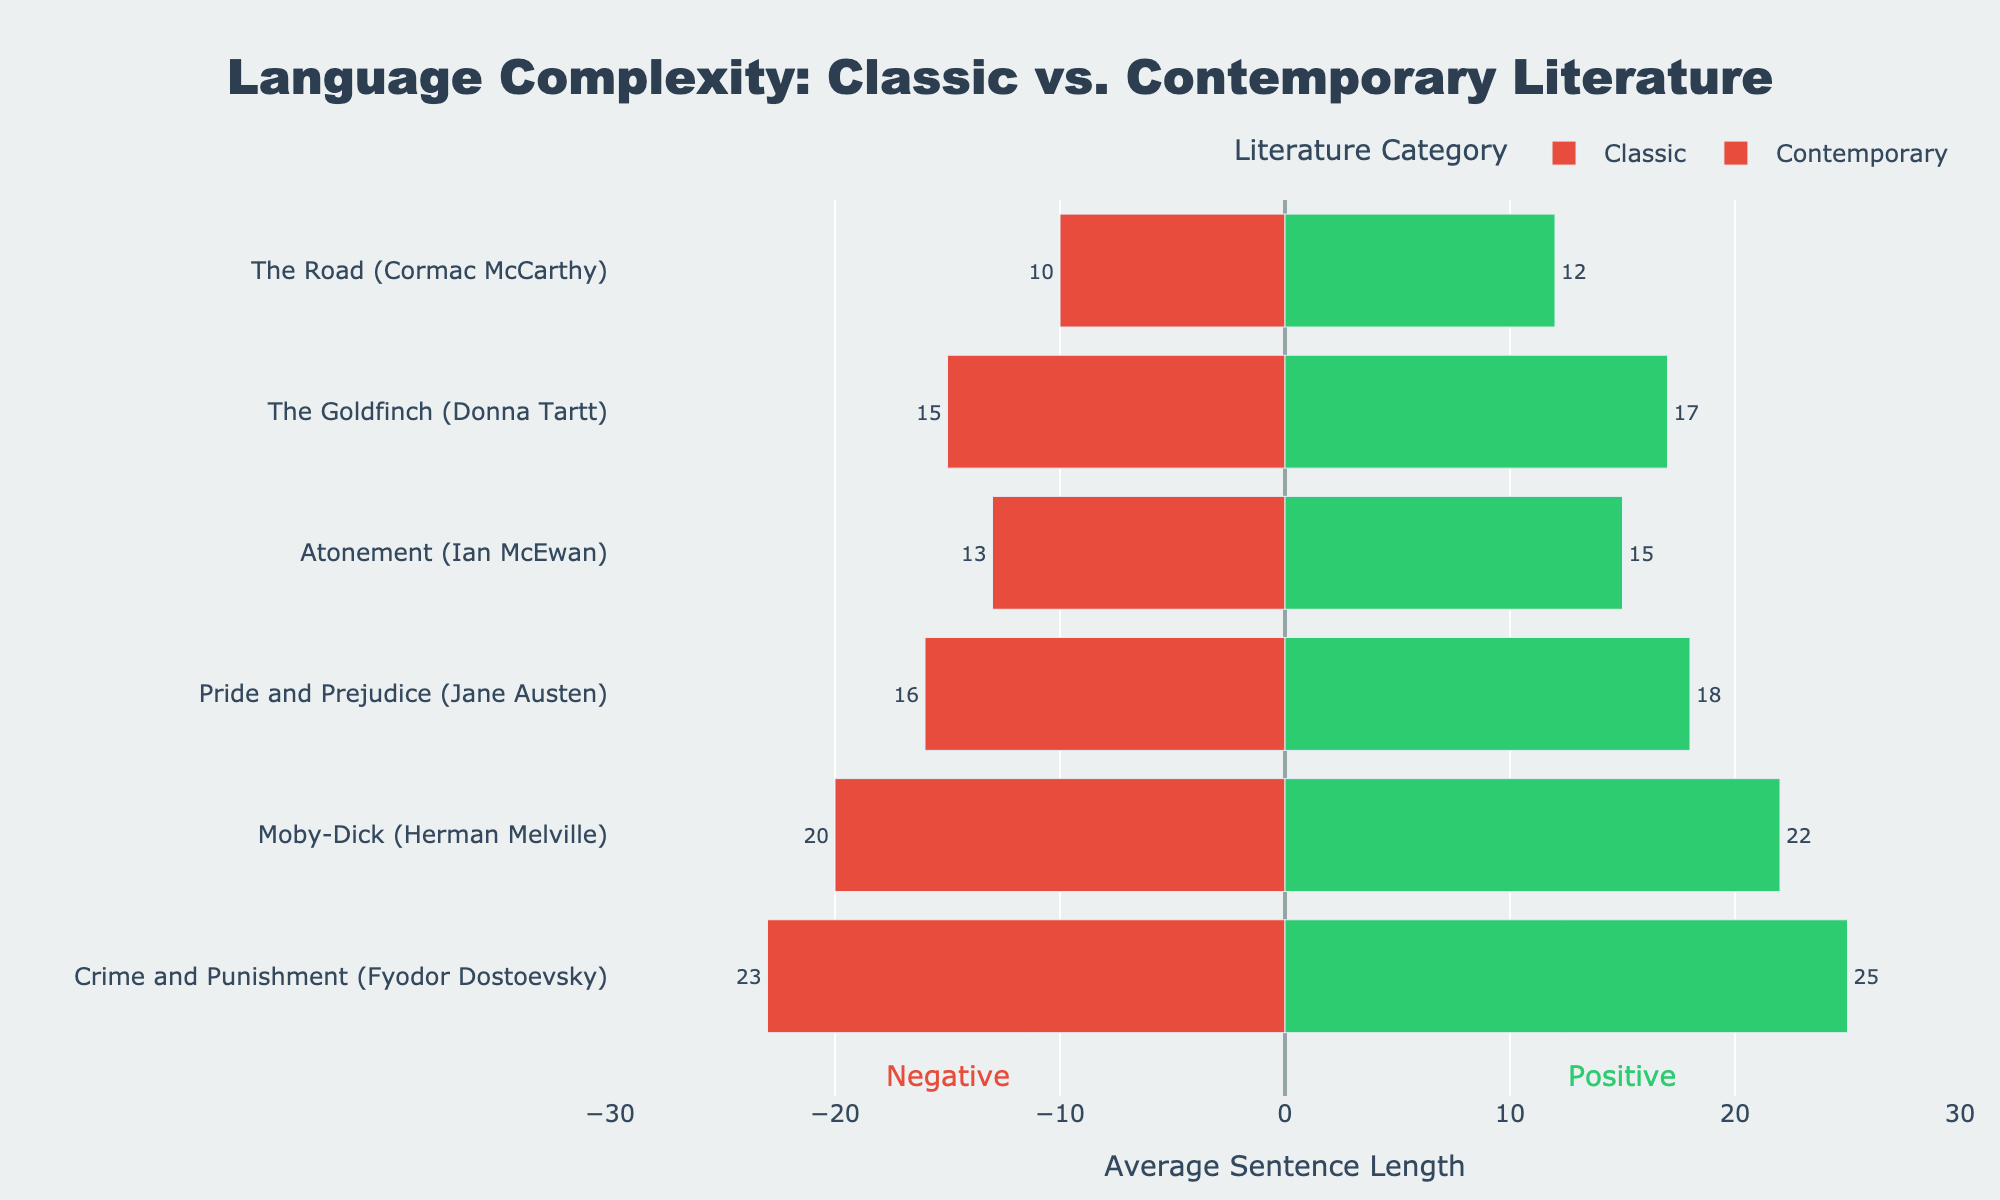Which book has the longest average positive sentence length in the Classic category? In the Classic category, "Crime and Punishment" by Fyodor Dostoevsky has the longest average positive sentence length of 25.
Answer: Crime and Punishment Which author's book has the shortest average negative sentence length in the Contemporary category? In the Contemporary category, "The Road" by Cormac McCarthy has the shortest average negative sentence length of 10.
Answer: Cormac McCarthy What is the difference in average positive sentence length between "Moby-Dick" and "Atonement"? The average positive sentence length for "Moby-Dick" is 22 and for "Atonement" is 15. The difference is 22 - 15 = 7.
Answer: 7 Which Classic book shows a greater difference between positive and negative average sentence lengths? "Crime and Punishment" has a difference of 25 - 23 = 2, "Moby-Dick" has a difference of 22 - 20 = 2, and "Pride and Prejudice" has a difference of 18 - 16 = 2. All three show an equal difference.
Answer: All equal Compare the average negative sentence lengths of "The Goldfinch" and "Pride and Prejudice". Which one is longer? "The Goldfinch" has an average negative sentence length of 15, whereas "Pride and Prejudice" has 16. 16 is longer than 15.
Answer: Pride and Prejudice Is there any book where both the positive and negative sentence lengths are the same? All books have different lengths for positive and negative sentences in the given data.
Answer: No In the Contemporary category, compare the total average sentence lengths (positive + negative) of "The Road" and "Atonement". Which one is larger? The total for "The Road" is 12 + 10 = 22, and for "Atonement" is 15 + 13 = 28. 28 is larger than 22.
Answer: Atonement Which book in the Classic category has the closest average positive and negative sentence lengths? For "Pride and Prejudice", the difference is 18 - 16 = 2, for "Moby-Dick" it is 22 - 20 = 2, and for "Crime and Punishment" it is 25 - 23 = 2. All have an equal difference.
Answer: All equal 